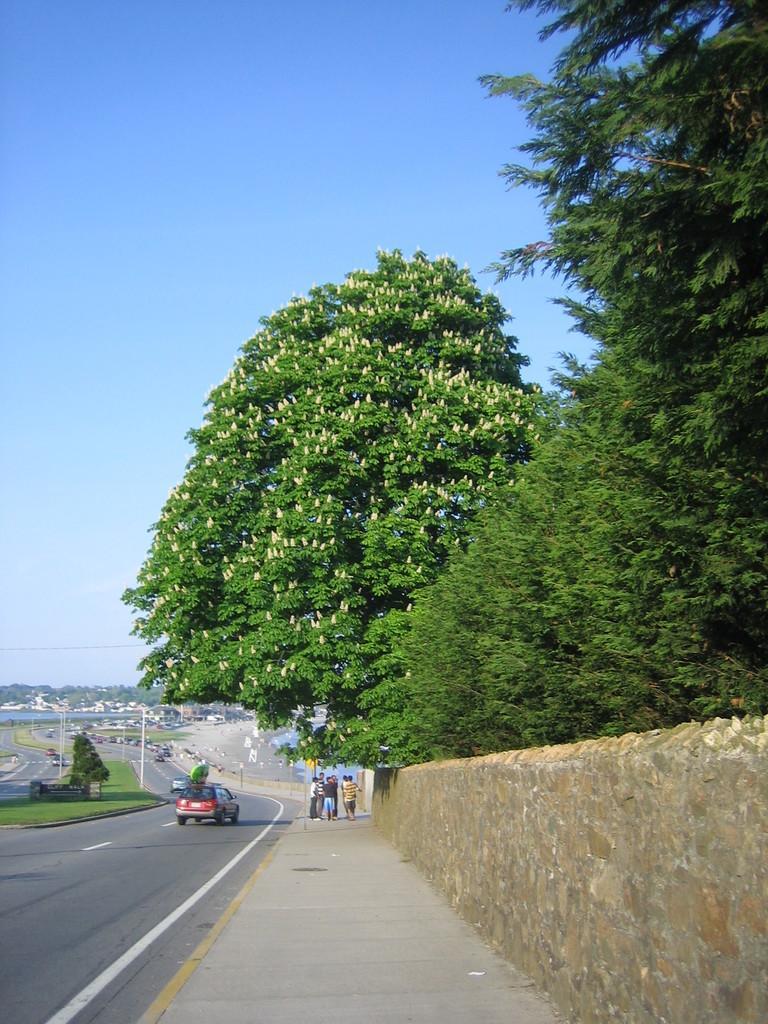Can you describe this image briefly? In this image we can see roads. On the roads there are vehicles. On the side of the road there is a sidewalk. Also there is a wall. And there are trees. On the sidewalk there are few people. In the back there is sky. 